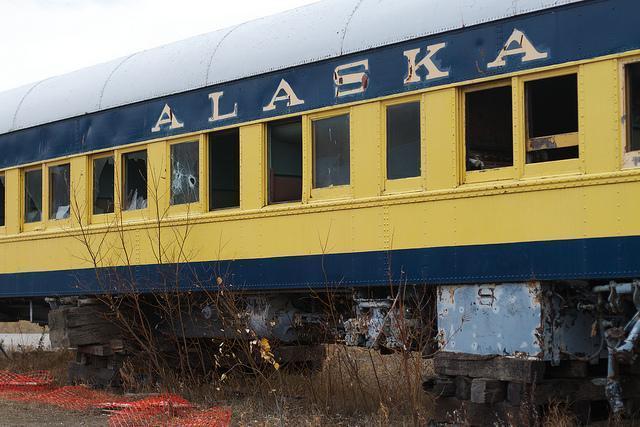How many people are there with facial hair?
Give a very brief answer. 0. 